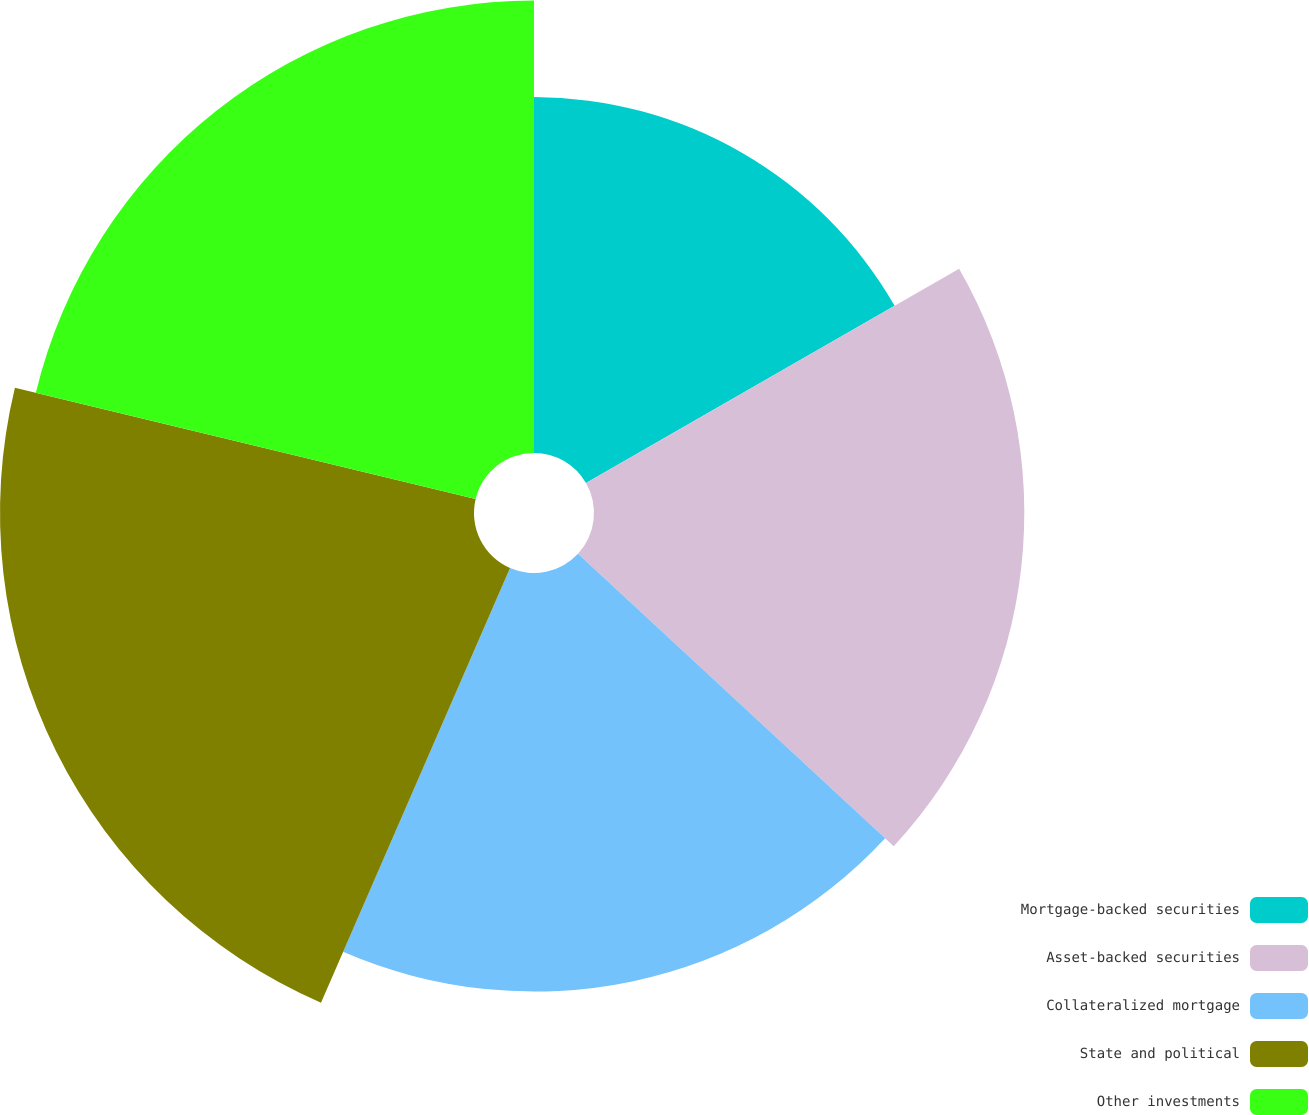Convert chart. <chart><loc_0><loc_0><loc_500><loc_500><pie_chart><fcel>Mortgage-backed securities<fcel>Asset-backed securities<fcel>Collateralized mortgage<fcel>State and political<fcel>Other investments<nl><fcel>16.7%<fcel>20.19%<fcel>19.64%<fcel>22.24%<fcel>21.23%<nl></chart> 